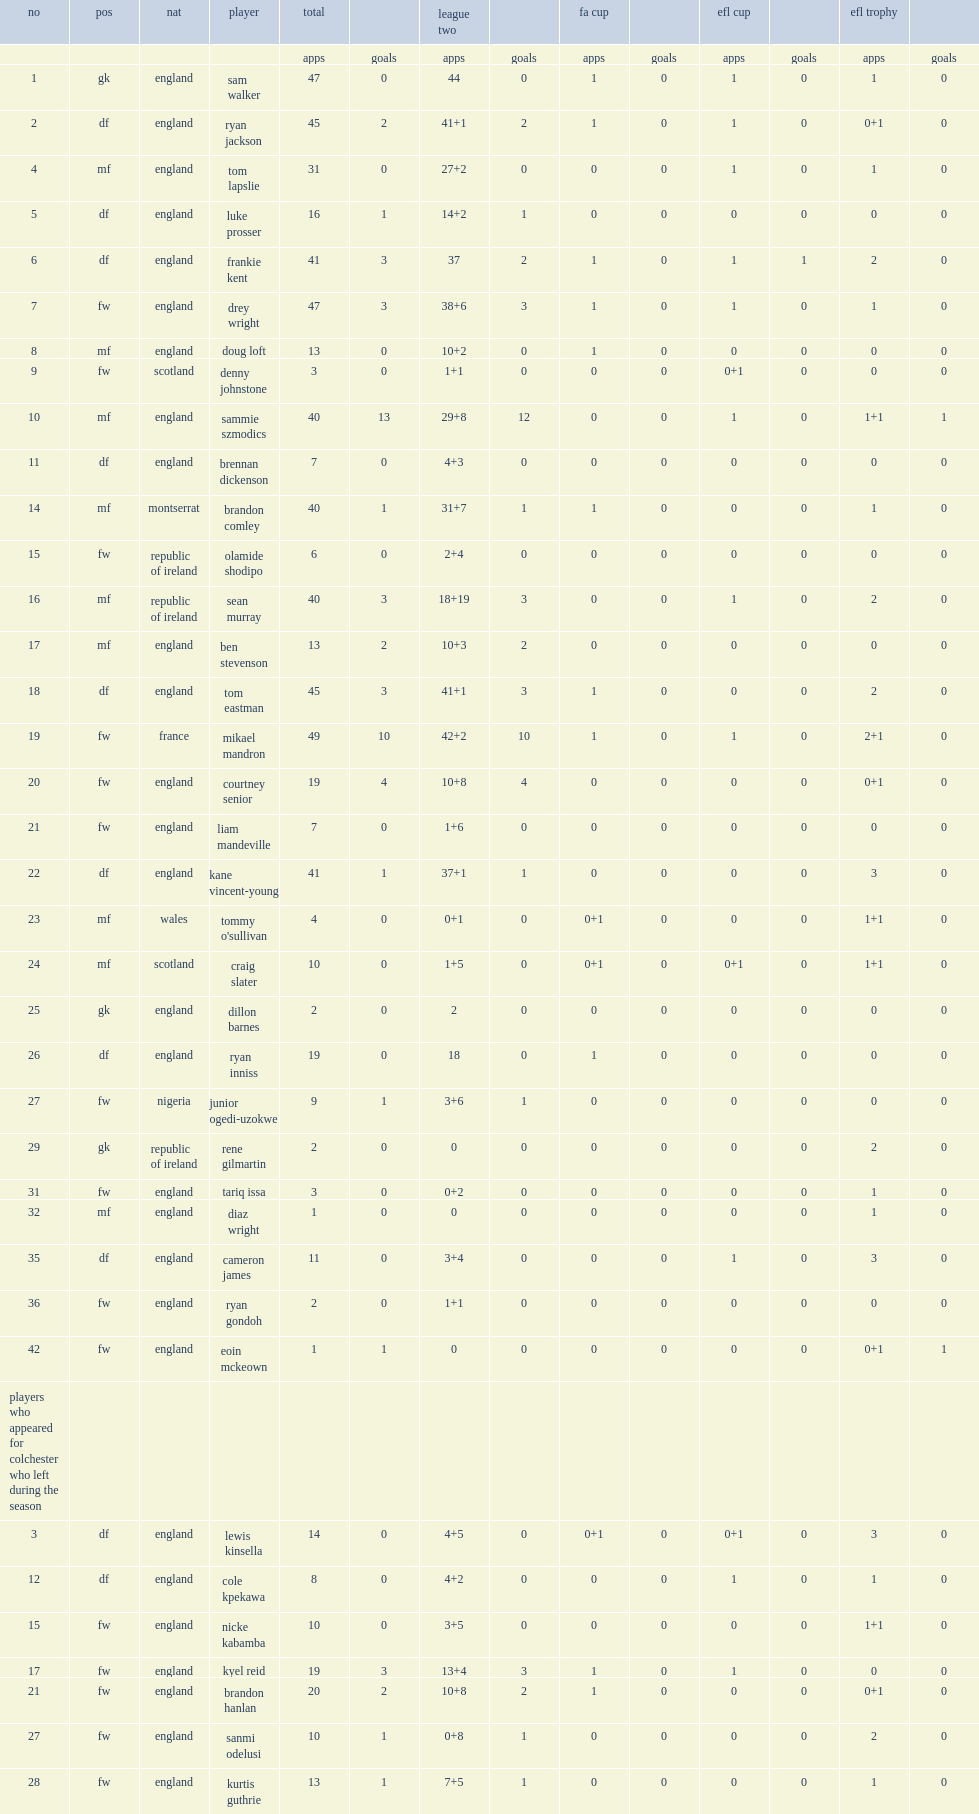Beside with competing in league two, what are the other cups and leagues that colchester united f.c. participated in? Fa cup efl cup efl trophy. 